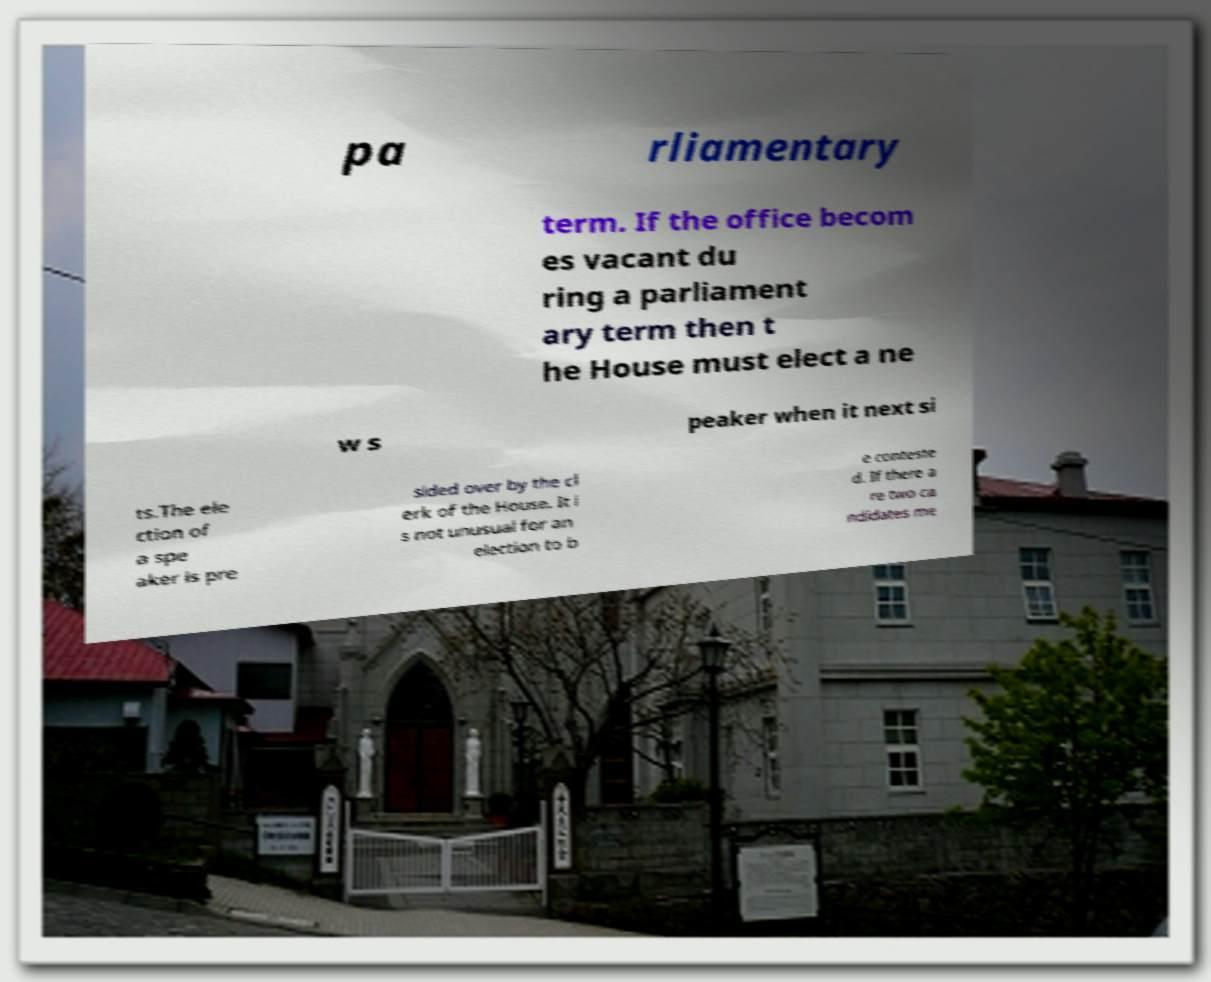What messages or text are displayed in this image? I need them in a readable, typed format. pa rliamentary term. If the office becom es vacant du ring a parliament ary term then t he House must elect a ne w s peaker when it next si ts.The ele ction of a spe aker is pre sided over by the cl erk of the House. It i s not unusual for an election to b e conteste d. If there a re two ca ndidates me 